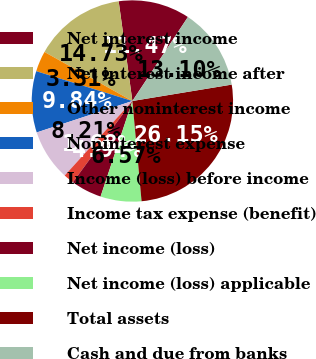Convert chart. <chart><loc_0><loc_0><loc_500><loc_500><pie_chart><fcel>Net interest income<fcel>Net interest income after<fcel>Other noninterest income<fcel>Noninterest expense<fcel>Income (loss) before income<fcel>Income tax expense (benefit)<fcel>Net income (loss)<fcel>Net income (loss) applicable<fcel>Total assets<fcel>Cash and due from banks<nl><fcel>11.47%<fcel>14.73%<fcel>3.31%<fcel>9.84%<fcel>8.21%<fcel>1.68%<fcel>4.94%<fcel>6.57%<fcel>26.15%<fcel>13.1%<nl></chart> 